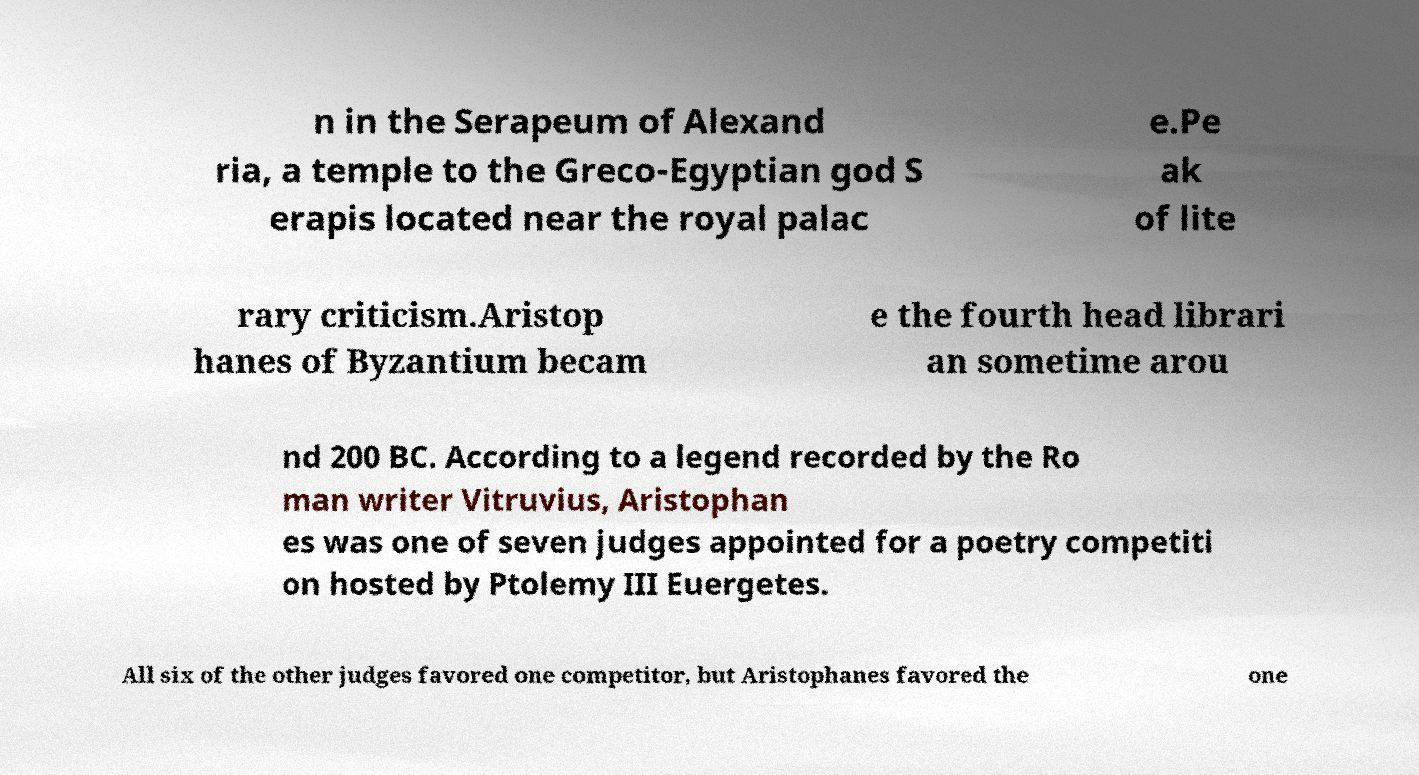There's text embedded in this image that I need extracted. Can you transcribe it verbatim? n in the Serapeum of Alexand ria, a temple to the Greco-Egyptian god S erapis located near the royal palac e.Pe ak of lite rary criticism.Aristop hanes of Byzantium becam e the fourth head librari an sometime arou nd 200 BC. According to a legend recorded by the Ro man writer Vitruvius, Aristophan es was one of seven judges appointed for a poetry competiti on hosted by Ptolemy III Euergetes. All six of the other judges favored one competitor, but Aristophanes favored the one 